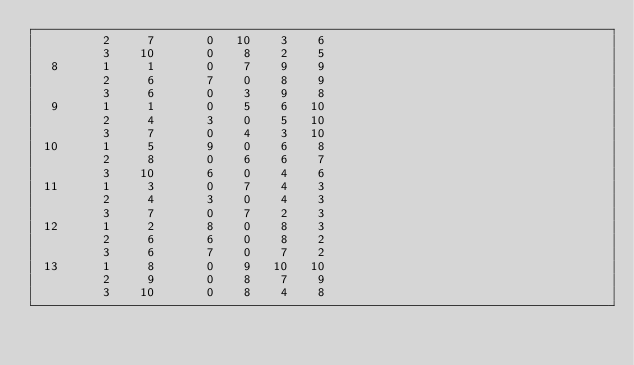Convert code to text. <code><loc_0><loc_0><loc_500><loc_500><_ObjectiveC_>         2     7       0   10    3    6
         3    10       0    8    2    5
  8      1     1       0    7    9    9
         2     6       7    0    8    9
         3     6       0    3    9    8
  9      1     1       0    5    6   10
         2     4       3    0    5   10
         3     7       0    4    3   10
 10      1     5       9    0    6    8
         2     8       0    6    6    7
         3    10       6    0    4    6
 11      1     3       0    7    4    3
         2     4       3    0    4    3
         3     7       0    7    2    3
 12      1     2       8    0    8    3
         2     6       6    0    8    2
         3     6       7    0    7    2
 13      1     8       0    9   10   10
         2     9       0    8    7    9
         3    10       0    8    4    8</code> 